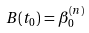Convert formula to latex. <formula><loc_0><loc_0><loc_500><loc_500>B ( t _ { 0 } ) = \beta _ { 0 } ^ { ( n ) }</formula> 